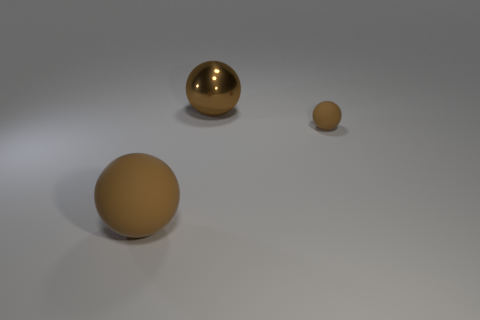What number of other things are there of the same color as the small ball?
Keep it short and to the point. 2. Is the color of the tiny thing the same as the large metal object?
Provide a short and direct response. Yes. What material is the big sphere that is the same color as the metallic thing?
Your answer should be compact. Rubber. What number of other big things have the same color as the large metallic thing?
Keep it short and to the point. 1. Does the small rubber object have the same color as the large object that is behind the small rubber ball?
Your answer should be compact. Yes. What size is the brown matte ball to the left of the tiny brown matte ball?
Give a very brief answer. Large. Are there any big things in front of the brown thing in front of the small rubber object?
Keep it short and to the point. No. What number of other objects are the same shape as the tiny matte object?
Make the answer very short. 2. Do the large rubber object and the tiny brown matte object have the same shape?
Provide a short and direct response. Yes. There is a sphere that is to the right of the big rubber ball and in front of the metallic sphere; what is its color?
Give a very brief answer. Brown. 